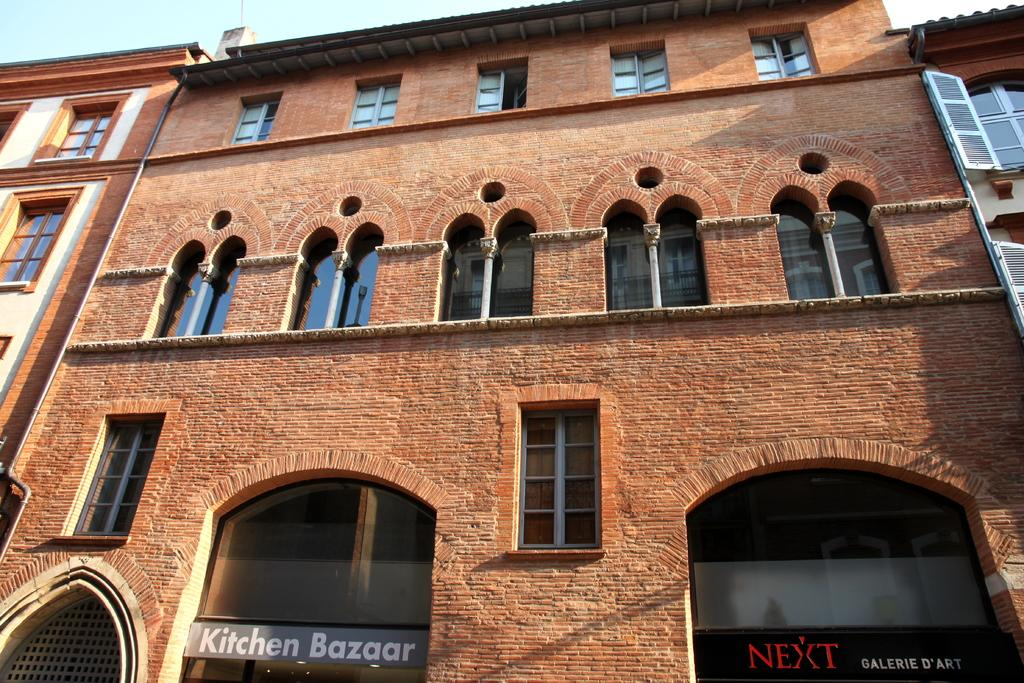What type of building is in the image? There is a brick building in the image. What feature can be seen on the building? The building has glass windows. What part of the natural environment is visible in the image? The sky is visible in the image. Can you tell me how many kitties are playing in the springtime afterthought section of the image? There are no kitties or springtime afterthought sections present in the image; it features a brick building with glass windows and a visible sky. 